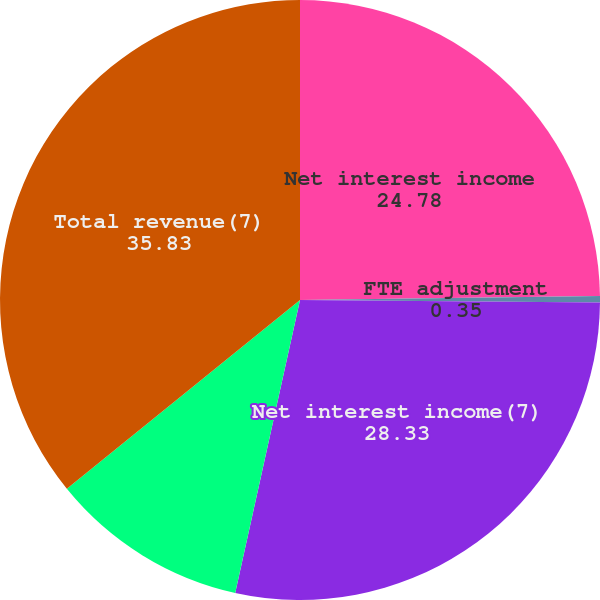Convert chart to OTSL. <chart><loc_0><loc_0><loc_500><loc_500><pie_chart><fcel>Net interest income<fcel>FTE adjustment<fcel>Net interest income(7)<fcel>Noninterest income<fcel>Total revenue(7)<nl><fcel>24.78%<fcel>0.35%<fcel>28.33%<fcel>10.7%<fcel>35.83%<nl></chart> 